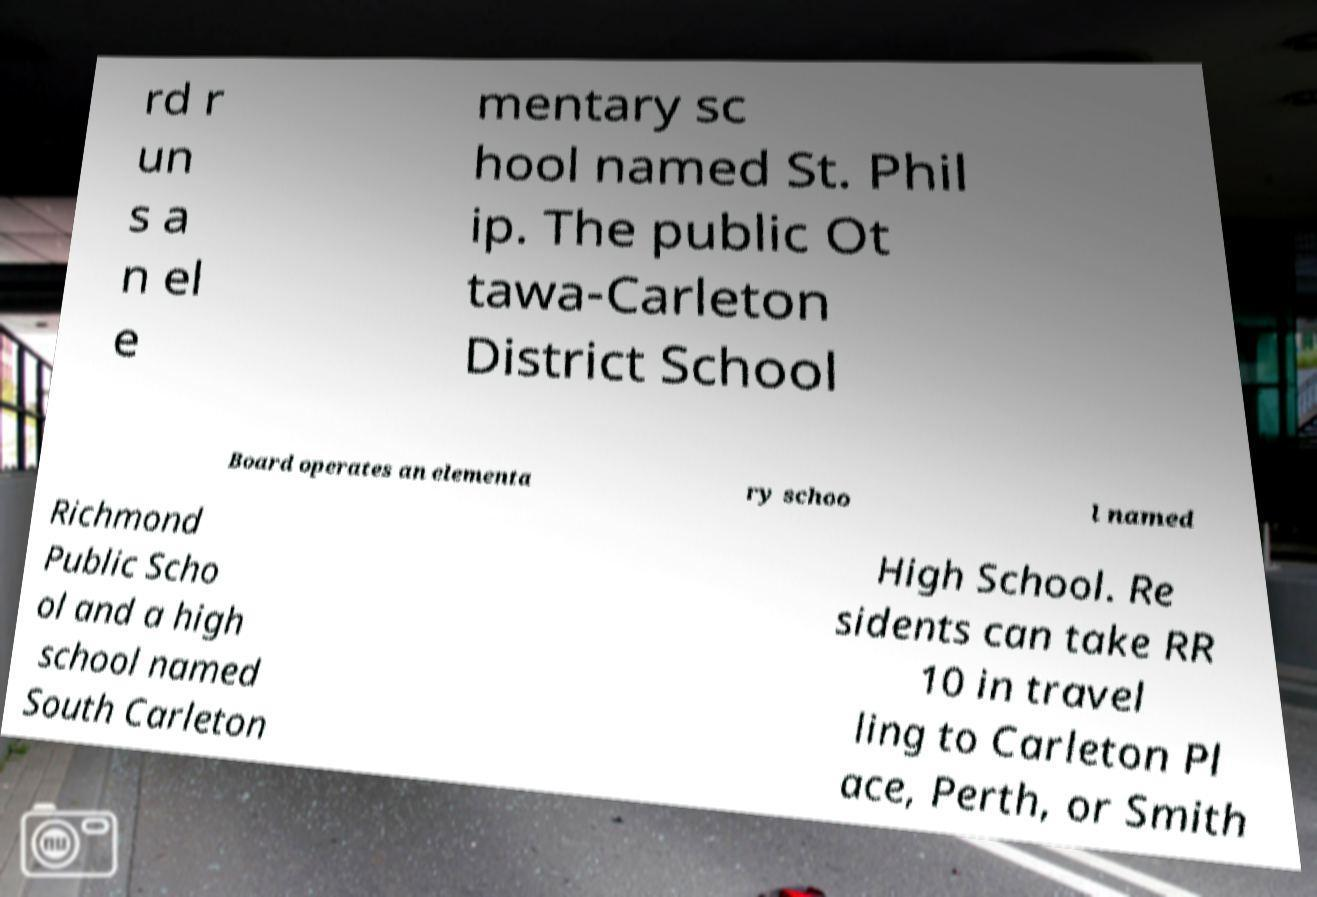Can you accurately transcribe the text from the provided image for me? rd r un s a n el e mentary sc hool named St. Phil ip. The public Ot tawa-Carleton District School Board operates an elementa ry schoo l named Richmond Public Scho ol and a high school named South Carleton High School. Re sidents can take RR 10 in travel ling to Carleton Pl ace, Perth, or Smith 